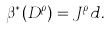Convert formula to latex. <formula><loc_0><loc_0><loc_500><loc_500>\beta ^ { * } ( D ^ { \rho } ) = J ^ { \rho } d .</formula> 